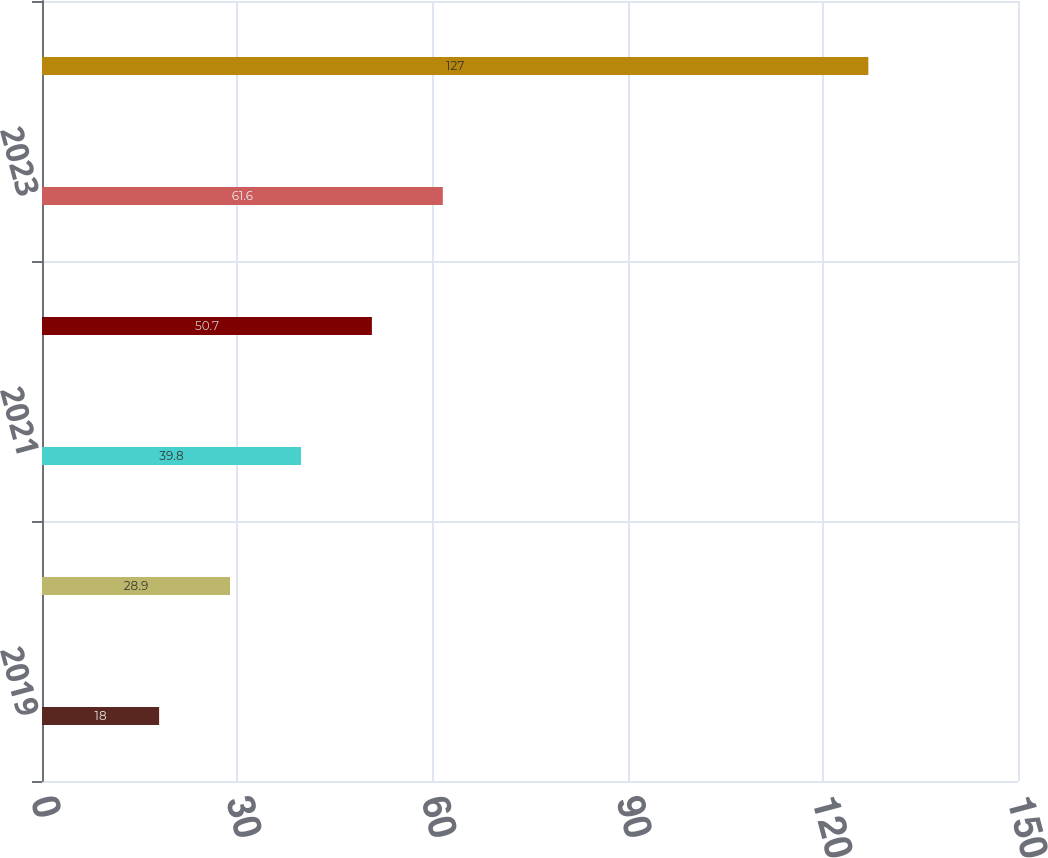<chart> <loc_0><loc_0><loc_500><loc_500><bar_chart><fcel>2019<fcel>2020<fcel>2021<fcel>2022<fcel>2023<fcel>2024 through 2028<nl><fcel>18<fcel>28.9<fcel>39.8<fcel>50.7<fcel>61.6<fcel>127<nl></chart> 